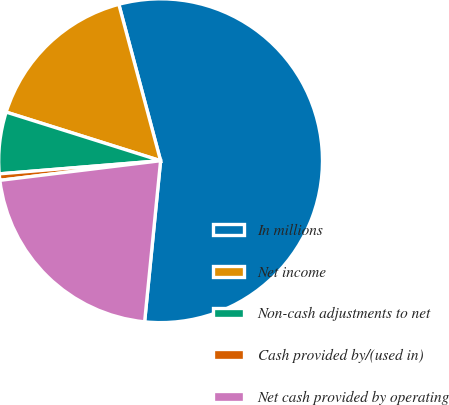Convert chart to OTSL. <chart><loc_0><loc_0><loc_500><loc_500><pie_chart><fcel>In millions<fcel>Net income<fcel>Non-cash adjustments to net<fcel>Cash provided by/(used in)<fcel>Net cash provided by operating<nl><fcel>55.72%<fcel>15.99%<fcel>6.15%<fcel>0.64%<fcel>21.49%<nl></chart> 